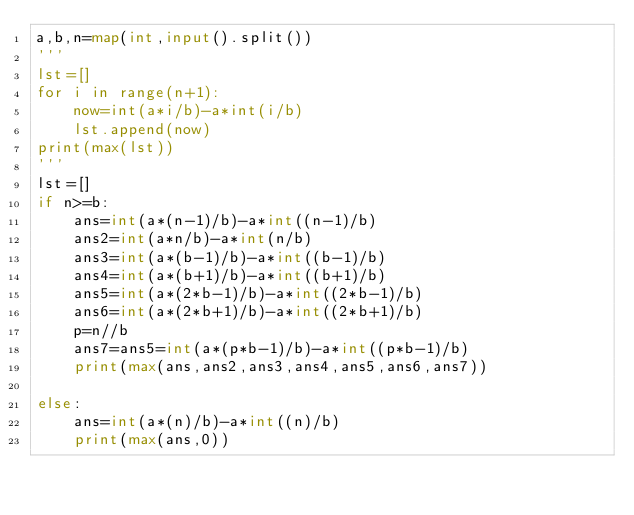<code> <loc_0><loc_0><loc_500><loc_500><_Python_>a,b,n=map(int,input().split())
'''
lst=[]
for i in range(n+1):
    now=int(a*i/b)-a*int(i/b)
    lst.append(now)
print(max(lst))
'''
lst=[]
if n>=b:
    ans=int(a*(n-1)/b)-a*int((n-1)/b)
    ans2=int(a*n/b)-a*int(n/b)
    ans3=int(a*(b-1)/b)-a*int((b-1)/b)
    ans4=int(a*(b+1)/b)-a*int((b+1)/b)
    ans5=int(a*(2*b-1)/b)-a*int((2*b-1)/b)
    ans6=int(a*(2*b+1)/b)-a*int((2*b+1)/b)
    p=n//b
    ans7=ans5=int(a*(p*b-1)/b)-a*int((p*b-1)/b)
    print(max(ans,ans2,ans3,ans4,ans5,ans6,ans7))

else:
    ans=int(a*(n)/b)-a*int((n)/b)
    print(max(ans,0))</code> 